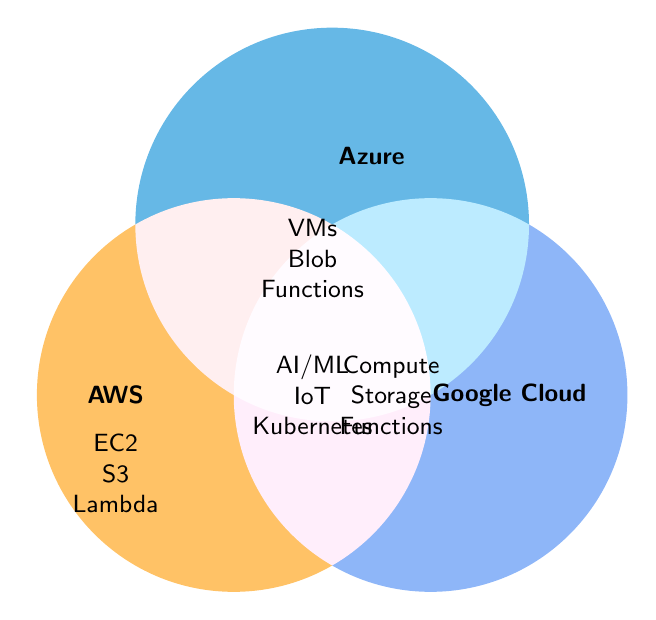What are the unique services offered by AWS? AWS offers Elastic Compute Cloud, S3 Storage, and Lambda as its unique services.
Answer: Elastic Compute Cloud, S3 Storage, Lambda What services are common to AWS, Azure, and Google Cloud? All three providers share AI/ML Services, IoT Solutions, and Kubernetes.
Answer: AI/ML Services, IoT Solutions, Kubernetes Which cloud service provider offers Blob Storage? From the Venn Diagram, Blob Storage is a service offered by Azure.
Answer: Azure How many unique services does each provider have? AWS offers 3 unique services, Azure offers 3 unique services, and Google Cloud offers 3 unique services. Additionally, there are 3 common services shared by all three providers.
Answer: AWS: 3, Azure: 3, Google Cloud: 3 Which services are offered only by Google Cloud and not by AWS or Azure? Google Cloud offers Compute Engine, Cloud Storage, and Cloud Functions as its unique services.
Answer: Compute Engine, Cloud Storage, Cloud Functions Do both AWS and Azure provide Virtual Machines? No, only Azure provides Virtual Machines.
Answer: No Are there any services exclusive to Azure? Yes, Azure offers Virtual Machines, Blob Storage, and Functions exclusively.
Answer: Virtual Machines, Blob Storage, Functions How many services in total are offered by Azure, including shared ones? Azure offers 3 unique services and shares 3 more with AWS and Google Cloud, totaling 6 services.
Answer: 6 Which providers offer a 'Compute' related service? AWS offers EC2, Azure offers Virtual Machines, and Google Cloud offers Compute Engine.
Answer: AWS, Azure, Google Cloud 